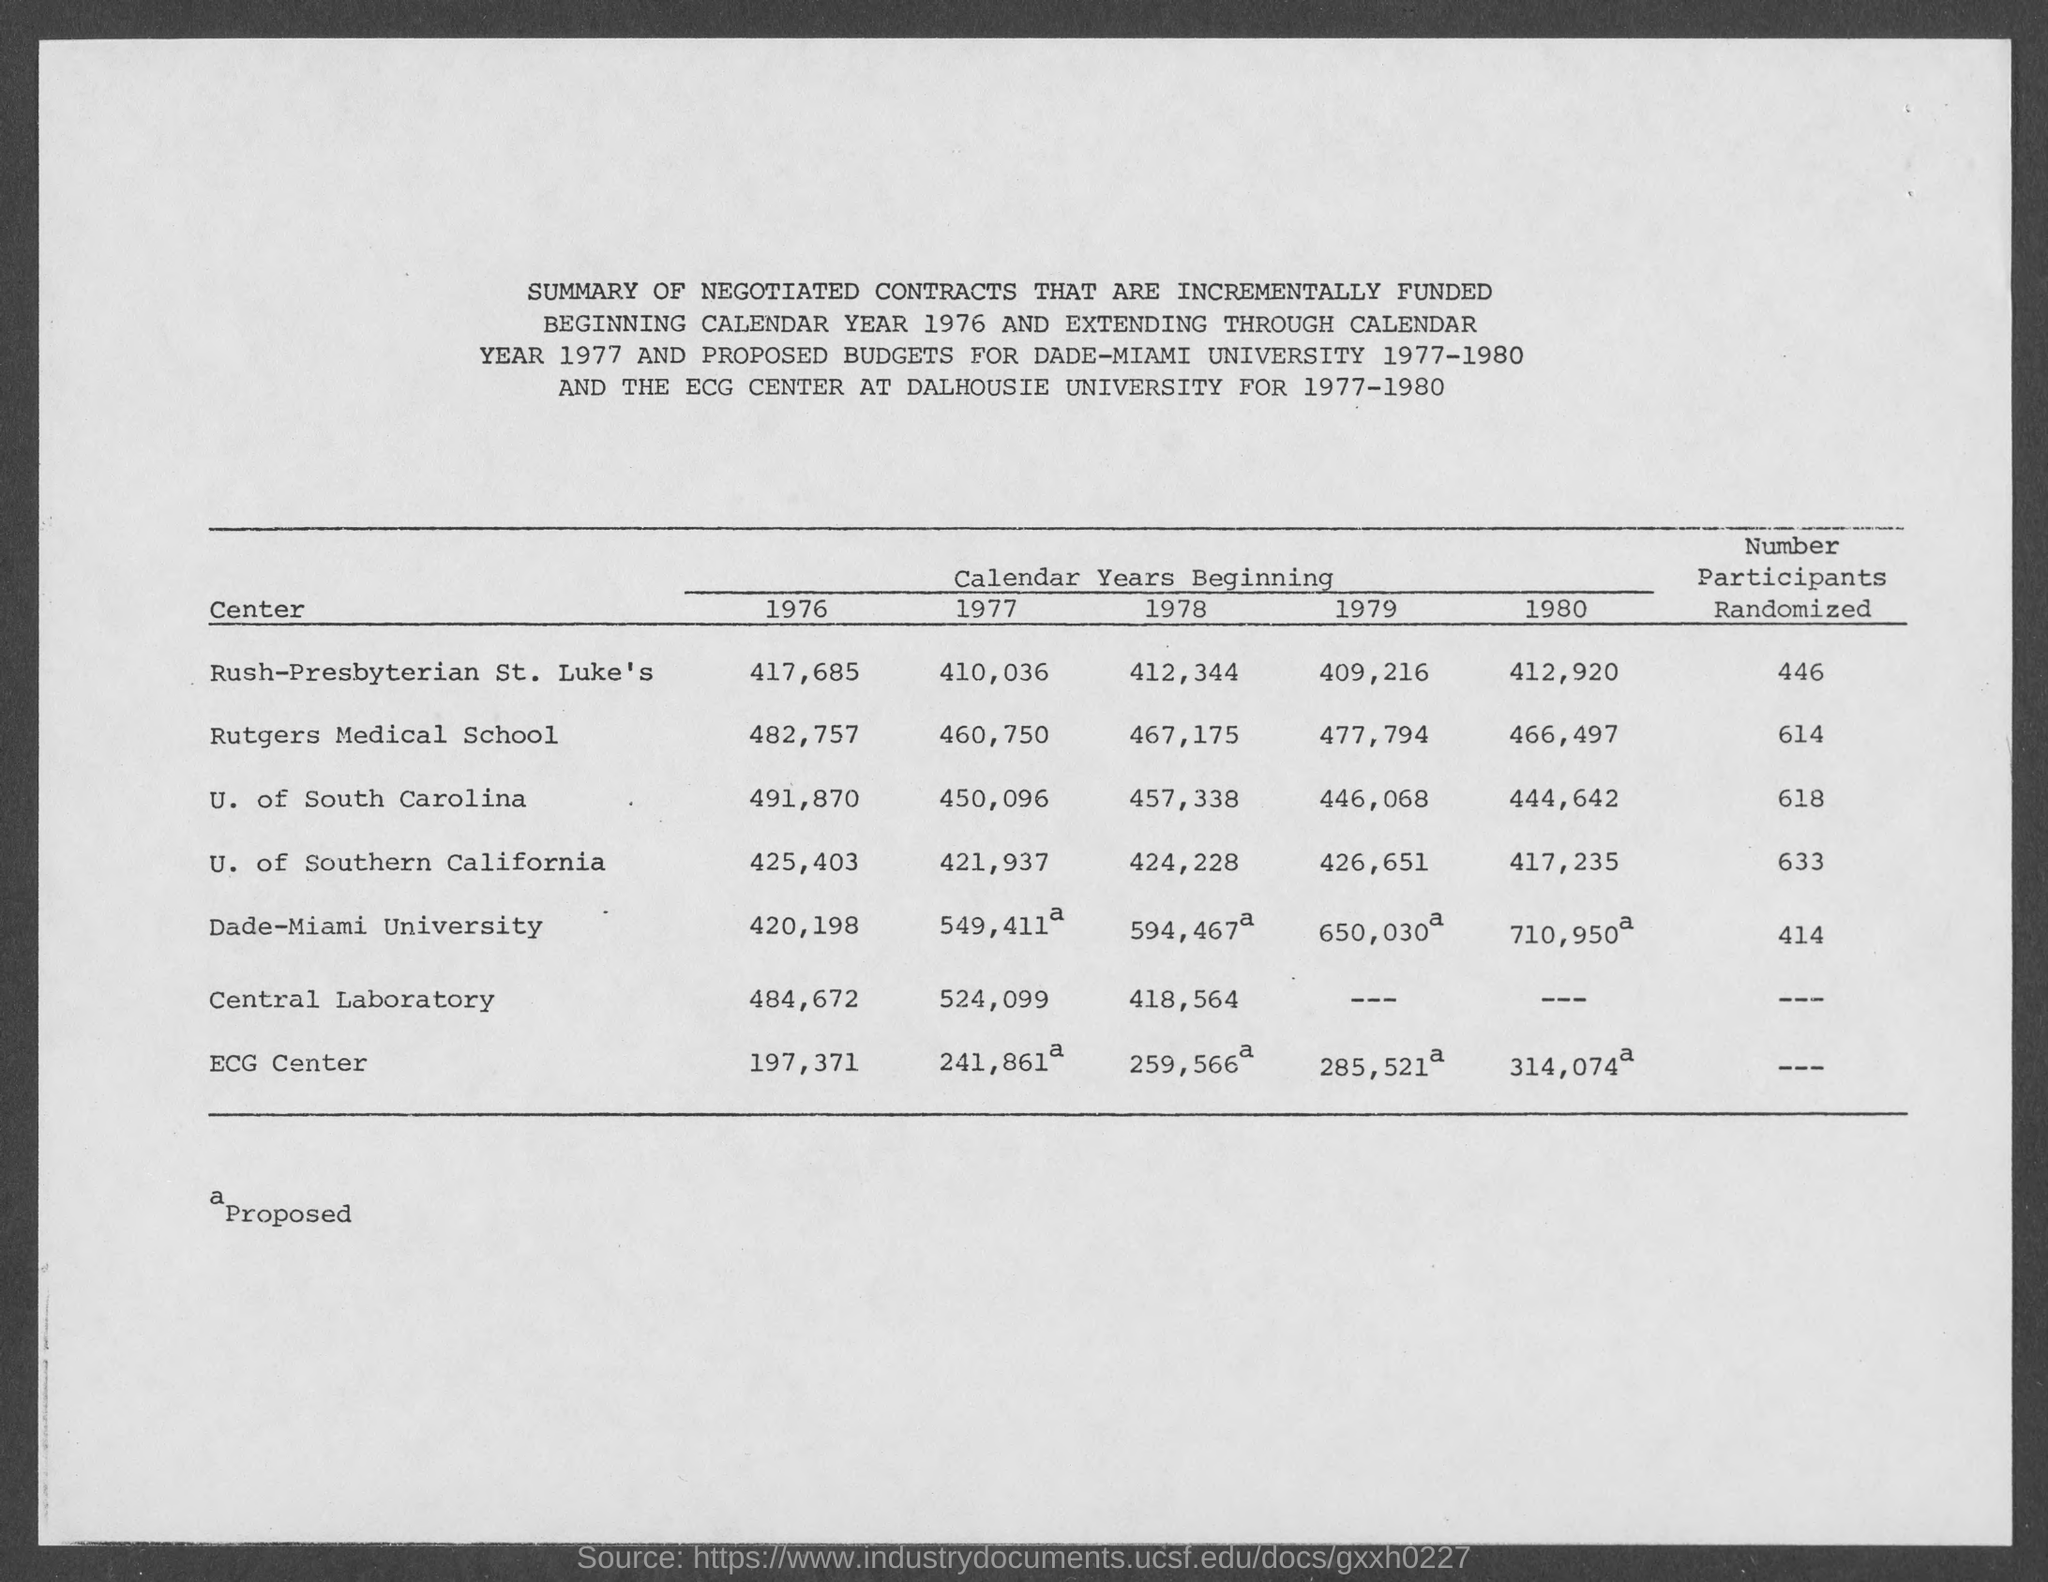What is the number of participants randomized in rush-presbyterian st. luke's center?
Ensure brevity in your answer.  446. What is the number of participants randomized in rutgers medical school center ?
Offer a terse response. 614. What is the number of participants randomized in u. of southern california center?
Offer a very short reply. 633. What is the number of participants randomized in u. of south carolina center?
Offer a very short reply. 618. What is the number of participants randomized in dade- miami university ?
Offer a terse response. 414. 